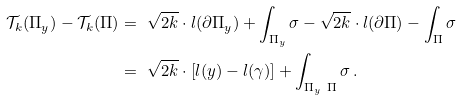<formula> <loc_0><loc_0><loc_500><loc_500>\mathcal { T } _ { k } ( \Pi _ { y } ) - \mathcal { T } _ { k } ( \Pi ) & = \ \sqrt { 2 k } \cdot l ( \partial \Pi _ { y } ) + \int _ { \Pi _ { y } } \sigma - \sqrt { 2 k } \cdot l ( \partial \Pi ) - \int _ { \Pi } \sigma \\ & = \ \sqrt { 2 k } \cdot \left [ l ( y ) - l ( \gamma ) \right ] + \int _ { \Pi _ { y } \ \Pi } \sigma \, .</formula> 